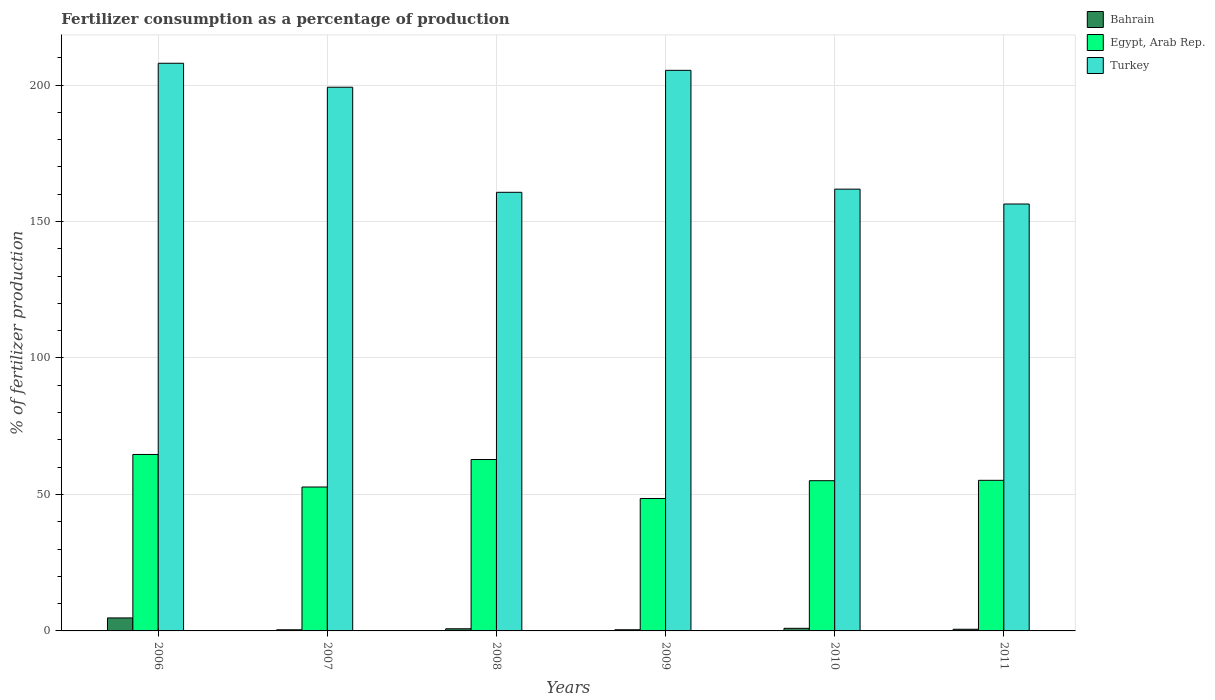How many groups of bars are there?
Keep it short and to the point. 6. Are the number of bars per tick equal to the number of legend labels?
Provide a short and direct response. Yes. Are the number of bars on each tick of the X-axis equal?
Provide a short and direct response. Yes. How many bars are there on the 3rd tick from the left?
Give a very brief answer. 3. What is the label of the 1st group of bars from the left?
Provide a succinct answer. 2006. In how many cases, is the number of bars for a given year not equal to the number of legend labels?
Your answer should be very brief. 0. What is the percentage of fertilizers consumed in Turkey in 2011?
Make the answer very short. 156.42. Across all years, what is the maximum percentage of fertilizers consumed in Turkey?
Offer a terse response. 207.99. Across all years, what is the minimum percentage of fertilizers consumed in Bahrain?
Your answer should be compact. 0.42. In which year was the percentage of fertilizers consumed in Egypt, Arab Rep. maximum?
Your response must be concise. 2006. In which year was the percentage of fertilizers consumed in Bahrain minimum?
Your answer should be very brief. 2007. What is the total percentage of fertilizers consumed in Turkey in the graph?
Make the answer very short. 1091.57. What is the difference between the percentage of fertilizers consumed in Egypt, Arab Rep. in 2008 and that in 2010?
Offer a terse response. 7.76. What is the difference between the percentage of fertilizers consumed in Bahrain in 2011 and the percentage of fertilizers consumed in Turkey in 2007?
Ensure brevity in your answer.  -198.6. What is the average percentage of fertilizers consumed in Bahrain per year?
Provide a short and direct response. 1.33. In the year 2008, what is the difference between the percentage of fertilizers consumed in Bahrain and percentage of fertilizers consumed in Turkey?
Ensure brevity in your answer.  -159.92. What is the ratio of the percentage of fertilizers consumed in Egypt, Arab Rep. in 2006 to that in 2008?
Your answer should be compact. 1.03. Is the percentage of fertilizers consumed in Bahrain in 2006 less than that in 2010?
Your response must be concise. No. Is the difference between the percentage of fertilizers consumed in Bahrain in 2007 and 2011 greater than the difference between the percentage of fertilizers consumed in Turkey in 2007 and 2011?
Provide a short and direct response. No. What is the difference between the highest and the second highest percentage of fertilizers consumed in Bahrain?
Keep it short and to the point. 3.81. What is the difference between the highest and the lowest percentage of fertilizers consumed in Egypt, Arab Rep.?
Provide a succinct answer. 16.13. Is the sum of the percentage of fertilizers consumed in Egypt, Arab Rep. in 2006 and 2009 greater than the maximum percentage of fertilizers consumed in Turkey across all years?
Offer a terse response. No. What does the 2nd bar from the left in 2010 represents?
Your answer should be very brief. Egypt, Arab Rep. What does the 3rd bar from the right in 2006 represents?
Your answer should be compact. Bahrain. How many bars are there?
Offer a very short reply. 18. Are all the bars in the graph horizontal?
Offer a very short reply. No. What is the difference between two consecutive major ticks on the Y-axis?
Keep it short and to the point. 50. Does the graph contain any zero values?
Ensure brevity in your answer.  No. Where does the legend appear in the graph?
Make the answer very short. Top right. How are the legend labels stacked?
Your answer should be very brief. Vertical. What is the title of the graph?
Provide a short and direct response. Fertilizer consumption as a percentage of production. What is the label or title of the Y-axis?
Make the answer very short. % of fertilizer production. What is the % of fertilizer production of Bahrain in 2006?
Your response must be concise. 4.76. What is the % of fertilizer production in Egypt, Arab Rep. in 2006?
Your response must be concise. 64.65. What is the % of fertilizer production in Turkey in 2006?
Provide a succinct answer. 207.99. What is the % of fertilizer production in Bahrain in 2007?
Give a very brief answer. 0.42. What is the % of fertilizer production in Egypt, Arab Rep. in 2007?
Your answer should be very brief. 52.73. What is the % of fertilizer production of Turkey in 2007?
Provide a short and direct response. 199.21. What is the % of fertilizer production of Bahrain in 2008?
Offer a terse response. 0.79. What is the % of fertilizer production of Egypt, Arab Rep. in 2008?
Your response must be concise. 62.8. What is the % of fertilizer production in Turkey in 2008?
Your answer should be very brief. 160.7. What is the % of fertilizer production in Bahrain in 2009?
Keep it short and to the point. 0.43. What is the % of fertilizer production in Egypt, Arab Rep. in 2009?
Provide a succinct answer. 48.52. What is the % of fertilizer production of Turkey in 2009?
Make the answer very short. 205.39. What is the % of fertilizer production in Bahrain in 2010?
Keep it short and to the point. 0.95. What is the % of fertilizer production in Egypt, Arab Rep. in 2010?
Ensure brevity in your answer.  55.04. What is the % of fertilizer production in Turkey in 2010?
Provide a succinct answer. 161.86. What is the % of fertilizer production in Bahrain in 2011?
Provide a succinct answer. 0.61. What is the % of fertilizer production in Egypt, Arab Rep. in 2011?
Keep it short and to the point. 55.18. What is the % of fertilizer production in Turkey in 2011?
Offer a terse response. 156.42. Across all years, what is the maximum % of fertilizer production of Bahrain?
Provide a short and direct response. 4.76. Across all years, what is the maximum % of fertilizer production of Egypt, Arab Rep.?
Provide a succinct answer. 64.65. Across all years, what is the maximum % of fertilizer production in Turkey?
Offer a very short reply. 207.99. Across all years, what is the minimum % of fertilizer production in Bahrain?
Ensure brevity in your answer.  0.42. Across all years, what is the minimum % of fertilizer production in Egypt, Arab Rep.?
Keep it short and to the point. 48.52. Across all years, what is the minimum % of fertilizer production of Turkey?
Your answer should be very brief. 156.42. What is the total % of fertilizer production of Bahrain in the graph?
Your answer should be very brief. 7.95. What is the total % of fertilizer production of Egypt, Arab Rep. in the graph?
Keep it short and to the point. 338.93. What is the total % of fertilizer production of Turkey in the graph?
Your answer should be very brief. 1091.57. What is the difference between the % of fertilizer production in Bahrain in 2006 and that in 2007?
Make the answer very short. 4.35. What is the difference between the % of fertilizer production in Egypt, Arab Rep. in 2006 and that in 2007?
Offer a very short reply. 11.92. What is the difference between the % of fertilizer production of Turkey in 2006 and that in 2007?
Offer a very short reply. 8.78. What is the difference between the % of fertilizer production in Bahrain in 2006 and that in 2008?
Your answer should be very brief. 3.98. What is the difference between the % of fertilizer production in Egypt, Arab Rep. in 2006 and that in 2008?
Your answer should be very brief. 1.85. What is the difference between the % of fertilizer production in Turkey in 2006 and that in 2008?
Offer a terse response. 47.28. What is the difference between the % of fertilizer production of Bahrain in 2006 and that in 2009?
Give a very brief answer. 4.33. What is the difference between the % of fertilizer production of Egypt, Arab Rep. in 2006 and that in 2009?
Offer a terse response. 16.13. What is the difference between the % of fertilizer production of Turkey in 2006 and that in 2009?
Offer a terse response. 2.59. What is the difference between the % of fertilizer production of Bahrain in 2006 and that in 2010?
Ensure brevity in your answer.  3.81. What is the difference between the % of fertilizer production in Egypt, Arab Rep. in 2006 and that in 2010?
Offer a very short reply. 9.61. What is the difference between the % of fertilizer production in Turkey in 2006 and that in 2010?
Your answer should be compact. 46.12. What is the difference between the % of fertilizer production of Bahrain in 2006 and that in 2011?
Provide a succinct answer. 4.15. What is the difference between the % of fertilizer production in Egypt, Arab Rep. in 2006 and that in 2011?
Offer a terse response. 9.47. What is the difference between the % of fertilizer production in Turkey in 2006 and that in 2011?
Provide a succinct answer. 51.57. What is the difference between the % of fertilizer production in Bahrain in 2007 and that in 2008?
Keep it short and to the point. -0.37. What is the difference between the % of fertilizer production of Egypt, Arab Rep. in 2007 and that in 2008?
Give a very brief answer. -10.07. What is the difference between the % of fertilizer production in Turkey in 2007 and that in 2008?
Offer a terse response. 38.5. What is the difference between the % of fertilizer production in Bahrain in 2007 and that in 2009?
Offer a terse response. -0.01. What is the difference between the % of fertilizer production in Egypt, Arab Rep. in 2007 and that in 2009?
Provide a short and direct response. 4.21. What is the difference between the % of fertilizer production of Turkey in 2007 and that in 2009?
Provide a short and direct response. -6.19. What is the difference between the % of fertilizer production in Bahrain in 2007 and that in 2010?
Offer a terse response. -0.54. What is the difference between the % of fertilizer production of Egypt, Arab Rep. in 2007 and that in 2010?
Keep it short and to the point. -2.31. What is the difference between the % of fertilizer production of Turkey in 2007 and that in 2010?
Keep it short and to the point. 37.34. What is the difference between the % of fertilizer production of Bahrain in 2007 and that in 2011?
Your response must be concise. -0.19. What is the difference between the % of fertilizer production in Egypt, Arab Rep. in 2007 and that in 2011?
Ensure brevity in your answer.  -2.45. What is the difference between the % of fertilizer production of Turkey in 2007 and that in 2011?
Your answer should be compact. 42.79. What is the difference between the % of fertilizer production in Bahrain in 2008 and that in 2009?
Provide a short and direct response. 0.36. What is the difference between the % of fertilizer production in Egypt, Arab Rep. in 2008 and that in 2009?
Ensure brevity in your answer.  14.28. What is the difference between the % of fertilizer production in Turkey in 2008 and that in 2009?
Make the answer very short. -44.69. What is the difference between the % of fertilizer production of Bahrain in 2008 and that in 2010?
Ensure brevity in your answer.  -0.17. What is the difference between the % of fertilizer production of Egypt, Arab Rep. in 2008 and that in 2010?
Give a very brief answer. 7.76. What is the difference between the % of fertilizer production of Turkey in 2008 and that in 2010?
Your answer should be compact. -1.16. What is the difference between the % of fertilizer production of Bahrain in 2008 and that in 2011?
Ensure brevity in your answer.  0.18. What is the difference between the % of fertilizer production of Egypt, Arab Rep. in 2008 and that in 2011?
Keep it short and to the point. 7.62. What is the difference between the % of fertilizer production in Turkey in 2008 and that in 2011?
Keep it short and to the point. 4.28. What is the difference between the % of fertilizer production of Bahrain in 2009 and that in 2010?
Offer a terse response. -0.52. What is the difference between the % of fertilizer production in Egypt, Arab Rep. in 2009 and that in 2010?
Offer a terse response. -6.52. What is the difference between the % of fertilizer production of Turkey in 2009 and that in 2010?
Ensure brevity in your answer.  43.53. What is the difference between the % of fertilizer production of Bahrain in 2009 and that in 2011?
Offer a very short reply. -0.18. What is the difference between the % of fertilizer production in Egypt, Arab Rep. in 2009 and that in 2011?
Your response must be concise. -6.66. What is the difference between the % of fertilizer production in Turkey in 2009 and that in 2011?
Provide a succinct answer. 48.98. What is the difference between the % of fertilizer production of Bahrain in 2010 and that in 2011?
Provide a short and direct response. 0.34. What is the difference between the % of fertilizer production of Egypt, Arab Rep. in 2010 and that in 2011?
Keep it short and to the point. -0.14. What is the difference between the % of fertilizer production of Turkey in 2010 and that in 2011?
Your answer should be compact. 5.44. What is the difference between the % of fertilizer production in Bahrain in 2006 and the % of fertilizer production in Egypt, Arab Rep. in 2007?
Ensure brevity in your answer.  -47.97. What is the difference between the % of fertilizer production of Bahrain in 2006 and the % of fertilizer production of Turkey in 2007?
Ensure brevity in your answer.  -194.44. What is the difference between the % of fertilizer production in Egypt, Arab Rep. in 2006 and the % of fertilizer production in Turkey in 2007?
Make the answer very short. -134.55. What is the difference between the % of fertilizer production in Bahrain in 2006 and the % of fertilizer production in Egypt, Arab Rep. in 2008?
Your response must be concise. -58.04. What is the difference between the % of fertilizer production of Bahrain in 2006 and the % of fertilizer production of Turkey in 2008?
Offer a terse response. -155.94. What is the difference between the % of fertilizer production of Egypt, Arab Rep. in 2006 and the % of fertilizer production of Turkey in 2008?
Provide a succinct answer. -96.05. What is the difference between the % of fertilizer production in Bahrain in 2006 and the % of fertilizer production in Egypt, Arab Rep. in 2009?
Offer a very short reply. -43.76. What is the difference between the % of fertilizer production of Bahrain in 2006 and the % of fertilizer production of Turkey in 2009?
Make the answer very short. -200.63. What is the difference between the % of fertilizer production in Egypt, Arab Rep. in 2006 and the % of fertilizer production in Turkey in 2009?
Make the answer very short. -140.74. What is the difference between the % of fertilizer production in Bahrain in 2006 and the % of fertilizer production in Egypt, Arab Rep. in 2010?
Provide a succinct answer. -50.28. What is the difference between the % of fertilizer production in Bahrain in 2006 and the % of fertilizer production in Turkey in 2010?
Make the answer very short. -157.1. What is the difference between the % of fertilizer production of Egypt, Arab Rep. in 2006 and the % of fertilizer production of Turkey in 2010?
Ensure brevity in your answer.  -97.21. What is the difference between the % of fertilizer production in Bahrain in 2006 and the % of fertilizer production in Egypt, Arab Rep. in 2011?
Provide a short and direct response. -50.42. What is the difference between the % of fertilizer production of Bahrain in 2006 and the % of fertilizer production of Turkey in 2011?
Keep it short and to the point. -151.66. What is the difference between the % of fertilizer production of Egypt, Arab Rep. in 2006 and the % of fertilizer production of Turkey in 2011?
Provide a succinct answer. -91.77. What is the difference between the % of fertilizer production of Bahrain in 2007 and the % of fertilizer production of Egypt, Arab Rep. in 2008?
Keep it short and to the point. -62.38. What is the difference between the % of fertilizer production of Bahrain in 2007 and the % of fertilizer production of Turkey in 2008?
Your answer should be very brief. -160.29. What is the difference between the % of fertilizer production in Egypt, Arab Rep. in 2007 and the % of fertilizer production in Turkey in 2008?
Give a very brief answer. -107.97. What is the difference between the % of fertilizer production in Bahrain in 2007 and the % of fertilizer production in Egypt, Arab Rep. in 2009?
Ensure brevity in your answer.  -48.11. What is the difference between the % of fertilizer production of Bahrain in 2007 and the % of fertilizer production of Turkey in 2009?
Keep it short and to the point. -204.98. What is the difference between the % of fertilizer production in Egypt, Arab Rep. in 2007 and the % of fertilizer production in Turkey in 2009?
Offer a terse response. -152.66. What is the difference between the % of fertilizer production in Bahrain in 2007 and the % of fertilizer production in Egypt, Arab Rep. in 2010?
Offer a very short reply. -54.63. What is the difference between the % of fertilizer production in Bahrain in 2007 and the % of fertilizer production in Turkey in 2010?
Your answer should be very brief. -161.45. What is the difference between the % of fertilizer production of Egypt, Arab Rep. in 2007 and the % of fertilizer production of Turkey in 2010?
Provide a succinct answer. -109.13. What is the difference between the % of fertilizer production in Bahrain in 2007 and the % of fertilizer production in Egypt, Arab Rep. in 2011?
Your answer should be very brief. -54.76. What is the difference between the % of fertilizer production of Bahrain in 2007 and the % of fertilizer production of Turkey in 2011?
Provide a short and direct response. -156. What is the difference between the % of fertilizer production in Egypt, Arab Rep. in 2007 and the % of fertilizer production in Turkey in 2011?
Make the answer very short. -103.69. What is the difference between the % of fertilizer production in Bahrain in 2008 and the % of fertilizer production in Egypt, Arab Rep. in 2009?
Your response must be concise. -47.74. What is the difference between the % of fertilizer production of Bahrain in 2008 and the % of fertilizer production of Turkey in 2009?
Offer a very short reply. -204.61. What is the difference between the % of fertilizer production of Egypt, Arab Rep. in 2008 and the % of fertilizer production of Turkey in 2009?
Your response must be concise. -142.6. What is the difference between the % of fertilizer production in Bahrain in 2008 and the % of fertilizer production in Egypt, Arab Rep. in 2010?
Keep it short and to the point. -54.26. What is the difference between the % of fertilizer production of Bahrain in 2008 and the % of fertilizer production of Turkey in 2010?
Provide a short and direct response. -161.08. What is the difference between the % of fertilizer production in Egypt, Arab Rep. in 2008 and the % of fertilizer production in Turkey in 2010?
Keep it short and to the point. -99.06. What is the difference between the % of fertilizer production in Bahrain in 2008 and the % of fertilizer production in Egypt, Arab Rep. in 2011?
Make the answer very short. -54.39. What is the difference between the % of fertilizer production of Bahrain in 2008 and the % of fertilizer production of Turkey in 2011?
Ensure brevity in your answer.  -155.63. What is the difference between the % of fertilizer production in Egypt, Arab Rep. in 2008 and the % of fertilizer production in Turkey in 2011?
Your response must be concise. -93.62. What is the difference between the % of fertilizer production of Bahrain in 2009 and the % of fertilizer production of Egypt, Arab Rep. in 2010?
Offer a very short reply. -54.62. What is the difference between the % of fertilizer production in Bahrain in 2009 and the % of fertilizer production in Turkey in 2010?
Give a very brief answer. -161.43. What is the difference between the % of fertilizer production in Egypt, Arab Rep. in 2009 and the % of fertilizer production in Turkey in 2010?
Offer a very short reply. -113.34. What is the difference between the % of fertilizer production in Bahrain in 2009 and the % of fertilizer production in Egypt, Arab Rep. in 2011?
Offer a terse response. -54.75. What is the difference between the % of fertilizer production of Bahrain in 2009 and the % of fertilizer production of Turkey in 2011?
Your answer should be very brief. -155.99. What is the difference between the % of fertilizer production in Egypt, Arab Rep. in 2009 and the % of fertilizer production in Turkey in 2011?
Make the answer very short. -107.9. What is the difference between the % of fertilizer production of Bahrain in 2010 and the % of fertilizer production of Egypt, Arab Rep. in 2011?
Provide a short and direct response. -54.23. What is the difference between the % of fertilizer production of Bahrain in 2010 and the % of fertilizer production of Turkey in 2011?
Give a very brief answer. -155.47. What is the difference between the % of fertilizer production in Egypt, Arab Rep. in 2010 and the % of fertilizer production in Turkey in 2011?
Your response must be concise. -101.38. What is the average % of fertilizer production in Bahrain per year?
Offer a terse response. 1.33. What is the average % of fertilizer production of Egypt, Arab Rep. per year?
Ensure brevity in your answer.  56.49. What is the average % of fertilizer production in Turkey per year?
Ensure brevity in your answer.  181.93. In the year 2006, what is the difference between the % of fertilizer production in Bahrain and % of fertilizer production in Egypt, Arab Rep.?
Your answer should be very brief. -59.89. In the year 2006, what is the difference between the % of fertilizer production of Bahrain and % of fertilizer production of Turkey?
Offer a terse response. -203.22. In the year 2006, what is the difference between the % of fertilizer production of Egypt, Arab Rep. and % of fertilizer production of Turkey?
Offer a very short reply. -143.33. In the year 2007, what is the difference between the % of fertilizer production of Bahrain and % of fertilizer production of Egypt, Arab Rep.?
Ensure brevity in your answer.  -52.31. In the year 2007, what is the difference between the % of fertilizer production of Bahrain and % of fertilizer production of Turkey?
Your response must be concise. -198.79. In the year 2007, what is the difference between the % of fertilizer production of Egypt, Arab Rep. and % of fertilizer production of Turkey?
Keep it short and to the point. -146.48. In the year 2008, what is the difference between the % of fertilizer production in Bahrain and % of fertilizer production in Egypt, Arab Rep.?
Your answer should be very brief. -62.01. In the year 2008, what is the difference between the % of fertilizer production in Bahrain and % of fertilizer production in Turkey?
Your answer should be very brief. -159.92. In the year 2008, what is the difference between the % of fertilizer production in Egypt, Arab Rep. and % of fertilizer production in Turkey?
Make the answer very short. -97.9. In the year 2009, what is the difference between the % of fertilizer production of Bahrain and % of fertilizer production of Egypt, Arab Rep.?
Offer a terse response. -48.09. In the year 2009, what is the difference between the % of fertilizer production in Bahrain and % of fertilizer production in Turkey?
Your answer should be very brief. -204.97. In the year 2009, what is the difference between the % of fertilizer production in Egypt, Arab Rep. and % of fertilizer production in Turkey?
Provide a succinct answer. -156.87. In the year 2010, what is the difference between the % of fertilizer production of Bahrain and % of fertilizer production of Egypt, Arab Rep.?
Your answer should be very brief. -54.09. In the year 2010, what is the difference between the % of fertilizer production of Bahrain and % of fertilizer production of Turkey?
Your answer should be compact. -160.91. In the year 2010, what is the difference between the % of fertilizer production in Egypt, Arab Rep. and % of fertilizer production in Turkey?
Offer a very short reply. -106.82. In the year 2011, what is the difference between the % of fertilizer production in Bahrain and % of fertilizer production in Egypt, Arab Rep.?
Make the answer very short. -54.57. In the year 2011, what is the difference between the % of fertilizer production in Bahrain and % of fertilizer production in Turkey?
Ensure brevity in your answer.  -155.81. In the year 2011, what is the difference between the % of fertilizer production in Egypt, Arab Rep. and % of fertilizer production in Turkey?
Ensure brevity in your answer.  -101.24. What is the ratio of the % of fertilizer production of Bahrain in 2006 to that in 2007?
Make the answer very short. 11.46. What is the ratio of the % of fertilizer production of Egypt, Arab Rep. in 2006 to that in 2007?
Your answer should be compact. 1.23. What is the ratio of the % of fertilizer production in Turkey in 2006 to that in 2007?
Provide a short and direct response. 1.04. What is the ratio of the % of fertilizer production of Bahrain in 2006 to that in 2008?
Keep it short and to the point. 6.05. What is the ratio of the % of fertilizer production in Egypt, Arab Rep. in 2006 to that in 2008?
Give a very brief answer. 1.03. What is the ratio of the % of fertilizer production in Turkey in 2006 to that in 2008?
Ensure brevity in your answer.  1.29. What is the ratio of the % of fertilizer production in Bahrain in 2006 to that in 2009?
Offer a terse response. 11.11. What is the ratio of the % of fertilizer production in Egypt, Arab Rep. in 2006 to that in 2009?
Keep it short and to the point. 1.33. What is the ratio of the % of fertilizer production of Turkey in 2006 to that in 2009?
Your answer should be very brief. 1.01. What is the ratio of the % of fertilizer production in Bahrain in 2006 to that in 2010?
Your response must be concise. 5. What is the ratio of the % of fertilizer production in Egypt, Arab Rep. in 2006 to that in 2010?
Your response must be concise. 1.17. What is the ratio of the % of fertilizer production of Turkey in 2006 to that in 2010?
Make the answer very short. 1.28. What is the ratio of the % of fertilizer production in Bahrain in 2006 to that in 2011?
Ensure brevity in your answer.  7.83. What is the ratio of the % of fertilizer production of Egypt, Arab Rep. in 2006 to that in 2011?
Offer a terse response. 1.17. What is the ratio of the % of fertilizer production in Turkey in 2006 to that in 2011?
Your answer should be very brief. 1.33. What is the ratio of the % of fertilizer production of Bahrain in 2007 to that in 2008?
Your answer should be compact. 0.53. What is the ratio of the % of fertilizer production of Egypt, Arab Rep. in 2007 to that in 2008?
Offer a very short reply. 0.84. What is the ratio of the % of fertilizer production of Turkey in 2007 to that in 2008?
Provide a short and direct response. 1.24. What is the ratio of the % of fertilizer production in Egypt, Arab Rep. in 2007 to that in 2009?
Offer a very short reply. 1.09. What is the ratio of the % of fertilizer production of Turkey in 2007 to that in 2009?
Give a very brief answer. 0.97. What is the ratio of the % of fertilizer production of Bahrain in 2007 to that in 2010?
Your response must be concise. 0.44. What is the ratio of the % of fertilizer production of Egypt, Arab Rep. in 2007 to that in 2010?
Your response must be concise. 0.96. What is the ratio of the % of fertilizer production of Turkey in 2007 to that in 2010?
Your response must be concise. 1.23. What is the ratio of the % of fertilizer production in Bahrain in 2007 to that in 2011?
Offer a very short reply. 0.68. What is the ratio of the % of fertilizer production of Egypt, Arab Rep. in 2007 to that in 2011?
Your answer should be compact. 0.96. What is the ratio of the % of fertilizer production in Turkey in 2007 to that in 2011?
Ensure brevity in your answer.  1.27. What is the ratio of the % of fertilizer production of Bahrain in 2008 to that in 2009?
Give a very brief answer. 1.84. What is the ratio of the % of fertilizer production in Egypt, Arab Rep. in 2008 to that in 2009?
Offer a terse response. 1.29. What is the ratio of the % of fertilizer production in Turkey in 2008 to that in 2009?
Provide a short and direct response. 0.78. What is the ratio of the % of fertilizer production of Bahrain in 2008 to that in 2010?
Your answer should be very brief. 0.83. What is the ratio of the % of fertilizer production in Egypt, Arab Rep. in 2008 to that in 2010?
Provide a short and direct response. 1.14. What is the ratio of the % of fertilizer production in Bahrain in 2008 to that in 2011?
Give a very brief answer. 1.29. What is the ratio of the % of fertilizer production of Egypt, Arab Rep. in 2008 to that in 2011?
Provide a succinct answer. 1.14. What is the ratio of the % of fertilizer production in Turkey in 2008 to that in 2011?
Keep it short and to the point. 1.03. What is the ratio of the % of fertilizer production in Bahrain in 2009 to that in 2010?
Your answer should be very brief. 0.45. What is the ratio of the % of fertilizer production in Egypt, Arab Rep. in 2009 to that in 2010?
Your answer should be compact. 0.88. What is the ratio of the % of fertilizer production in Turkey in 2009 to that in 2010?
Offer a very short reply. 1.27. What is the ratio of the % of fertilizer production in Bahrain in 2009 to that in 2011?
Keep it short and to the point. 0.7. What is the ratio of the % of fertilizer production of Egypt, Arab Rep. in 2009 to that in 2011?
Your answer should be compact. 0.88. What is the ratio of the % of fertilizer production of Turkey in 2009 to that in 2011?
Your answer should be very brief. 1.31. What is the ratio of the % of fertilizer production in Bahrain in 2010 to that in 2011?
Offer a terse response. 1.57. What is the ratio of the % of fertilizer production of Egypt, Arab Rep. in 2010 to that in 2011?
Make the answer very short. 1. What is the ratio of the % of fertilizer production of Turkey in 2010 to that in 2011?
Offer a terse response. 1.03. What is the difference between the highest and the second highest % of fertilizer production in Bahrain?
Your answer should be very brief. 3.81. What is the difference between the highest and the second highest % of fertilizer production in Egypt, Arab Rep.?
Your response must be concise. 1.85. What is the difference between the highest and the second highest % of fertilizer production in Turkey?
Ensure brevity in your answer.  2.59. What is the difference between the highest and the lowest % of fertilizer production in Bahrain?
Provide a succinct answer. 4.35. What is the difference between the highest and the lowest % of fertilizer production in Egypt, Arab Rep.?
Your answer should be very brief. 16.13. What is the difference between the highest and the lowest % of fertilizer production of Turkey?
Make the answer very short. 51.57. 